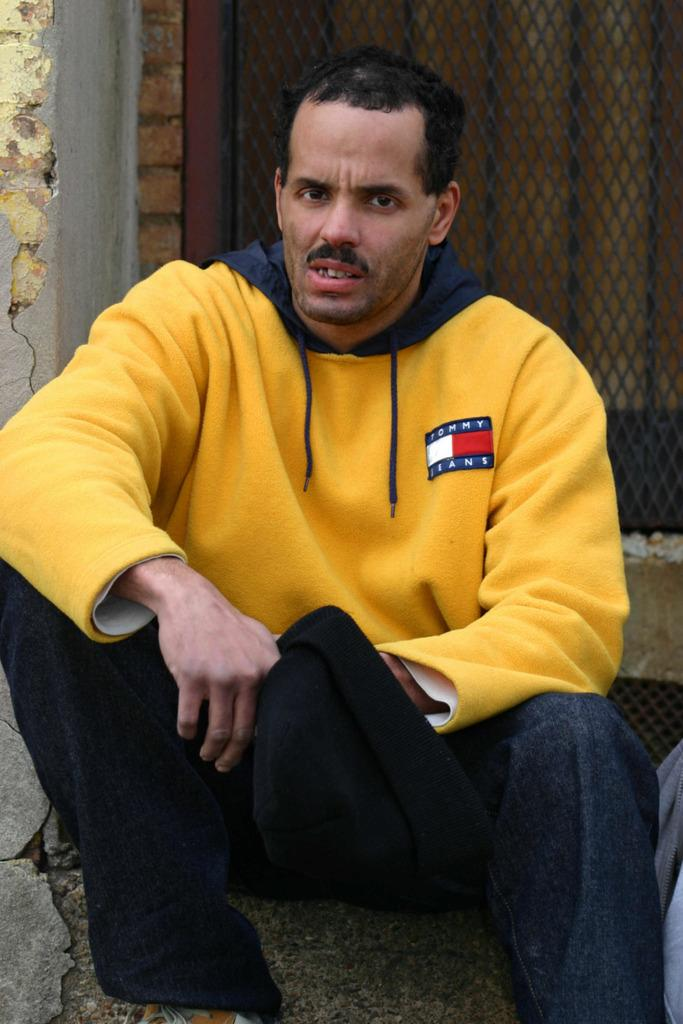Who is present in the image? There is a man in the image. What is the man wearing? The man is wearing a yellow hoodie and a pant. What is the man holding in his hand? The man is holding a black cap in his hand. What can be seen in the background of the image? There is a window in the image, and it has a mesh. What is the taste of the land in the image? There is no land present in the image, so it is not possible to determine its taste. 